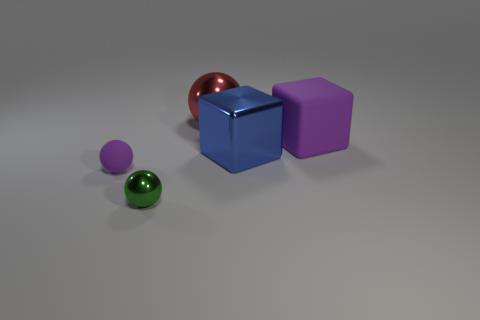How would you describe the arrangement of the objects? The objects are arranged asymmetrically with generous spacing on a neutral surface. There's a clear organization by size, with the two spheres positioned on the left and the cubes to the right, while a reflective sphere sits closest to the foreground, drawing immediate attention. 